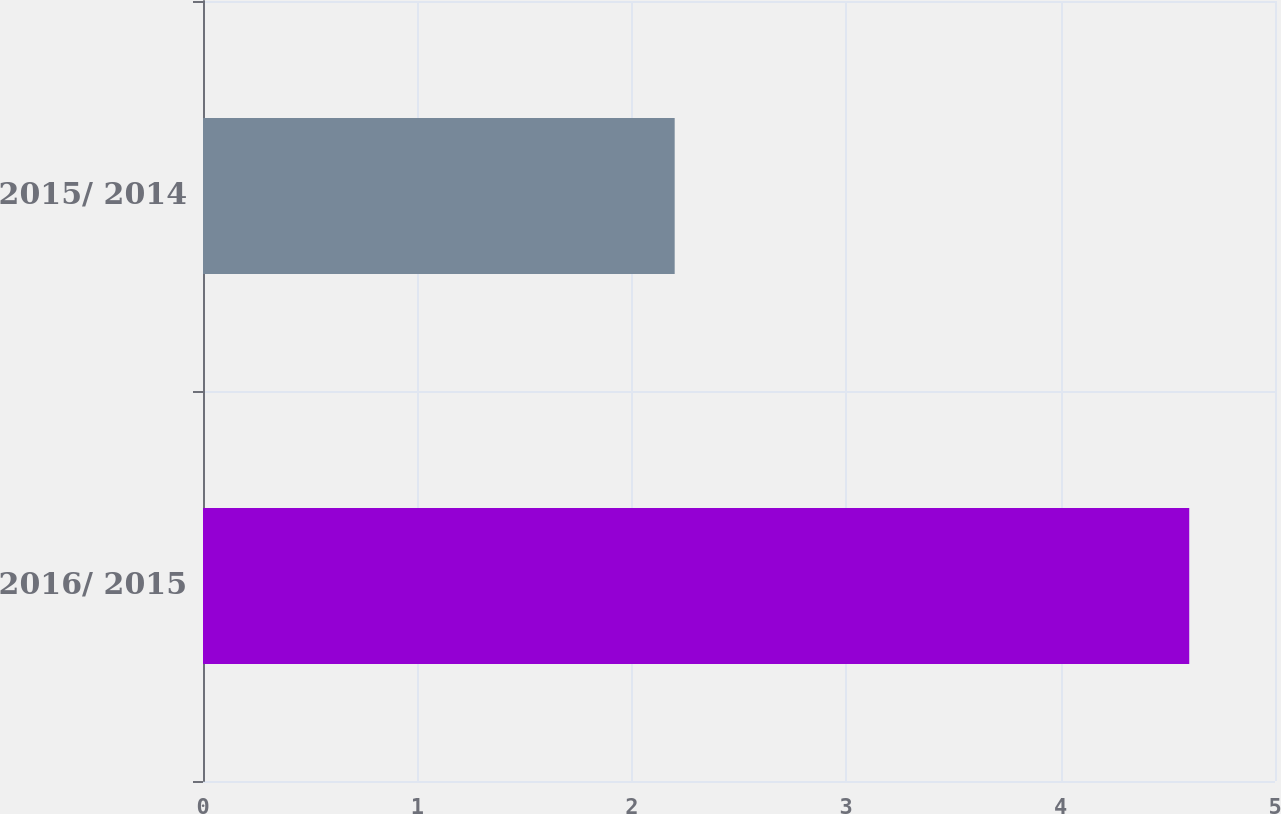Convert chart. <chart><loc_0><loc_0><loc_500><loc_500><bar_chart><fcel>2016/ 2015<fcel>2015/ 2014<nl><fcel>4.6<fcel>2.2<nl></chart> 